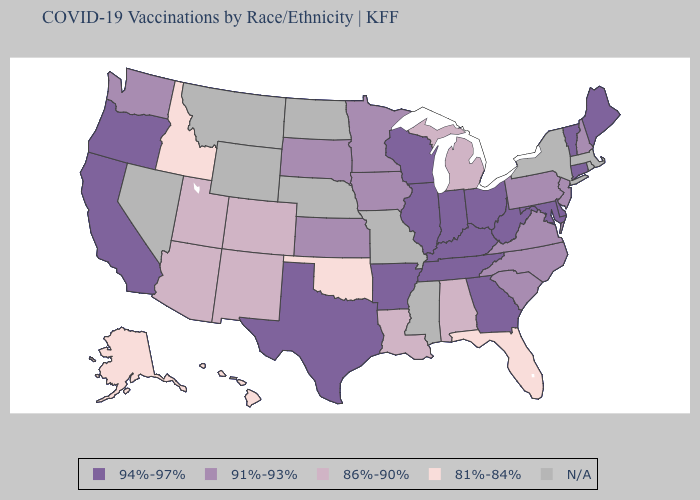Which states hav the highest value in the South?
Answer briefly. Arkansas, Delaware, Georgia, Kentucky, Maryland, Tennessee, Texas, West Virginia. What is the highest value in states that border Wyoming?
Keep it brief. 91%-93%. Does the map have missing data?
Write a very short answer. Yes. What is the value of New Mexico?
Keep it brief. 86%-90%. Name the states that have a value in the range 94%-97%?
Quick response, please. Arkansas, California, Connecticut, Delaware, Georgia, Illinois, Indiana, Kentucky, Maine, Maryland, Ohio, Oregon, Tennessee, Texas, Vermont, West Virginia, Wisconsin. Name the states that have a value in the range 94%-97%?
Quick response, please. Arkansas, California, Connecticut, Delaware, Georgia, Illinois, Indiana, Kentucky, Maine, Maryland, Ohio, Oregon, Tennessee, Texas, Vermont, West Virginia, Wisconsin. Among the states that border Idaho , does Utah have the lowest value?
Short answer required. Yes. Which states have the lowest value in the South?
Concise answer only. Florida, Oklahoma. Name the states that have a value in the range 91%-93%?
Concise answer only. Iowa, Kansas, Minnesota, New Hampshire, New Jersey, North Carolina, Pennsylvania, South Carolina, South Dakota, Virginia, Washington. How many symbols are there in the legend?
Give a very brief answer. 5. What is the value of New Jersey?
Give a very brief answer. 91%-93%. Name the states that have a value in the range 94%-97%?
Write a very short answer. Arkansas, California, Connecticut, Delaware, Georgia, Illinois, Indiana, Kentucky, Maine, Maryland, Ohio, Oregon, Tennessee, Texas, Vermont, West Virginia, Wisconsin. Does South Carolina have the highest value in the USA?
Give a very brief answer. No. What is the highest value in states that border Wyoming?
Keep it brief. 91%-93%. Does the first symbol in the legend represent the smallest category?
Short answer required. No. 